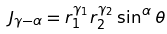<formula> <loc_0><loc_0><loc_500><loc_500>J _ { \gamma - \alpha } = r _ { 1 } ^ { \gamma _ { 1 } } r _ { 2 } ^ { \gamma _ { 2 } } \sin ^ { \alpha } { \theta }</formula> 